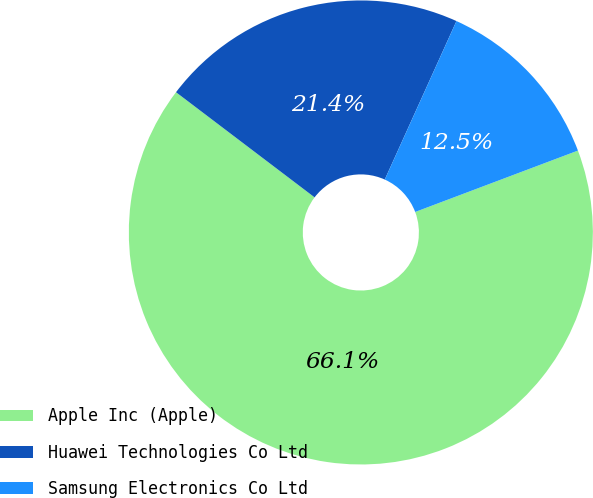Convert chart to OTSL. <chart><loc_0><loc_0><loc_500><loc_500><pie_chart><fcel>Apple Inc (Apple)<fcel>Huawei Technologies Co Ltd<fcel>Samsung Electronics Co Ltd<nl><fcel>66.07%<fcel>21.43%<fcel>12.5%<nl></chart> 